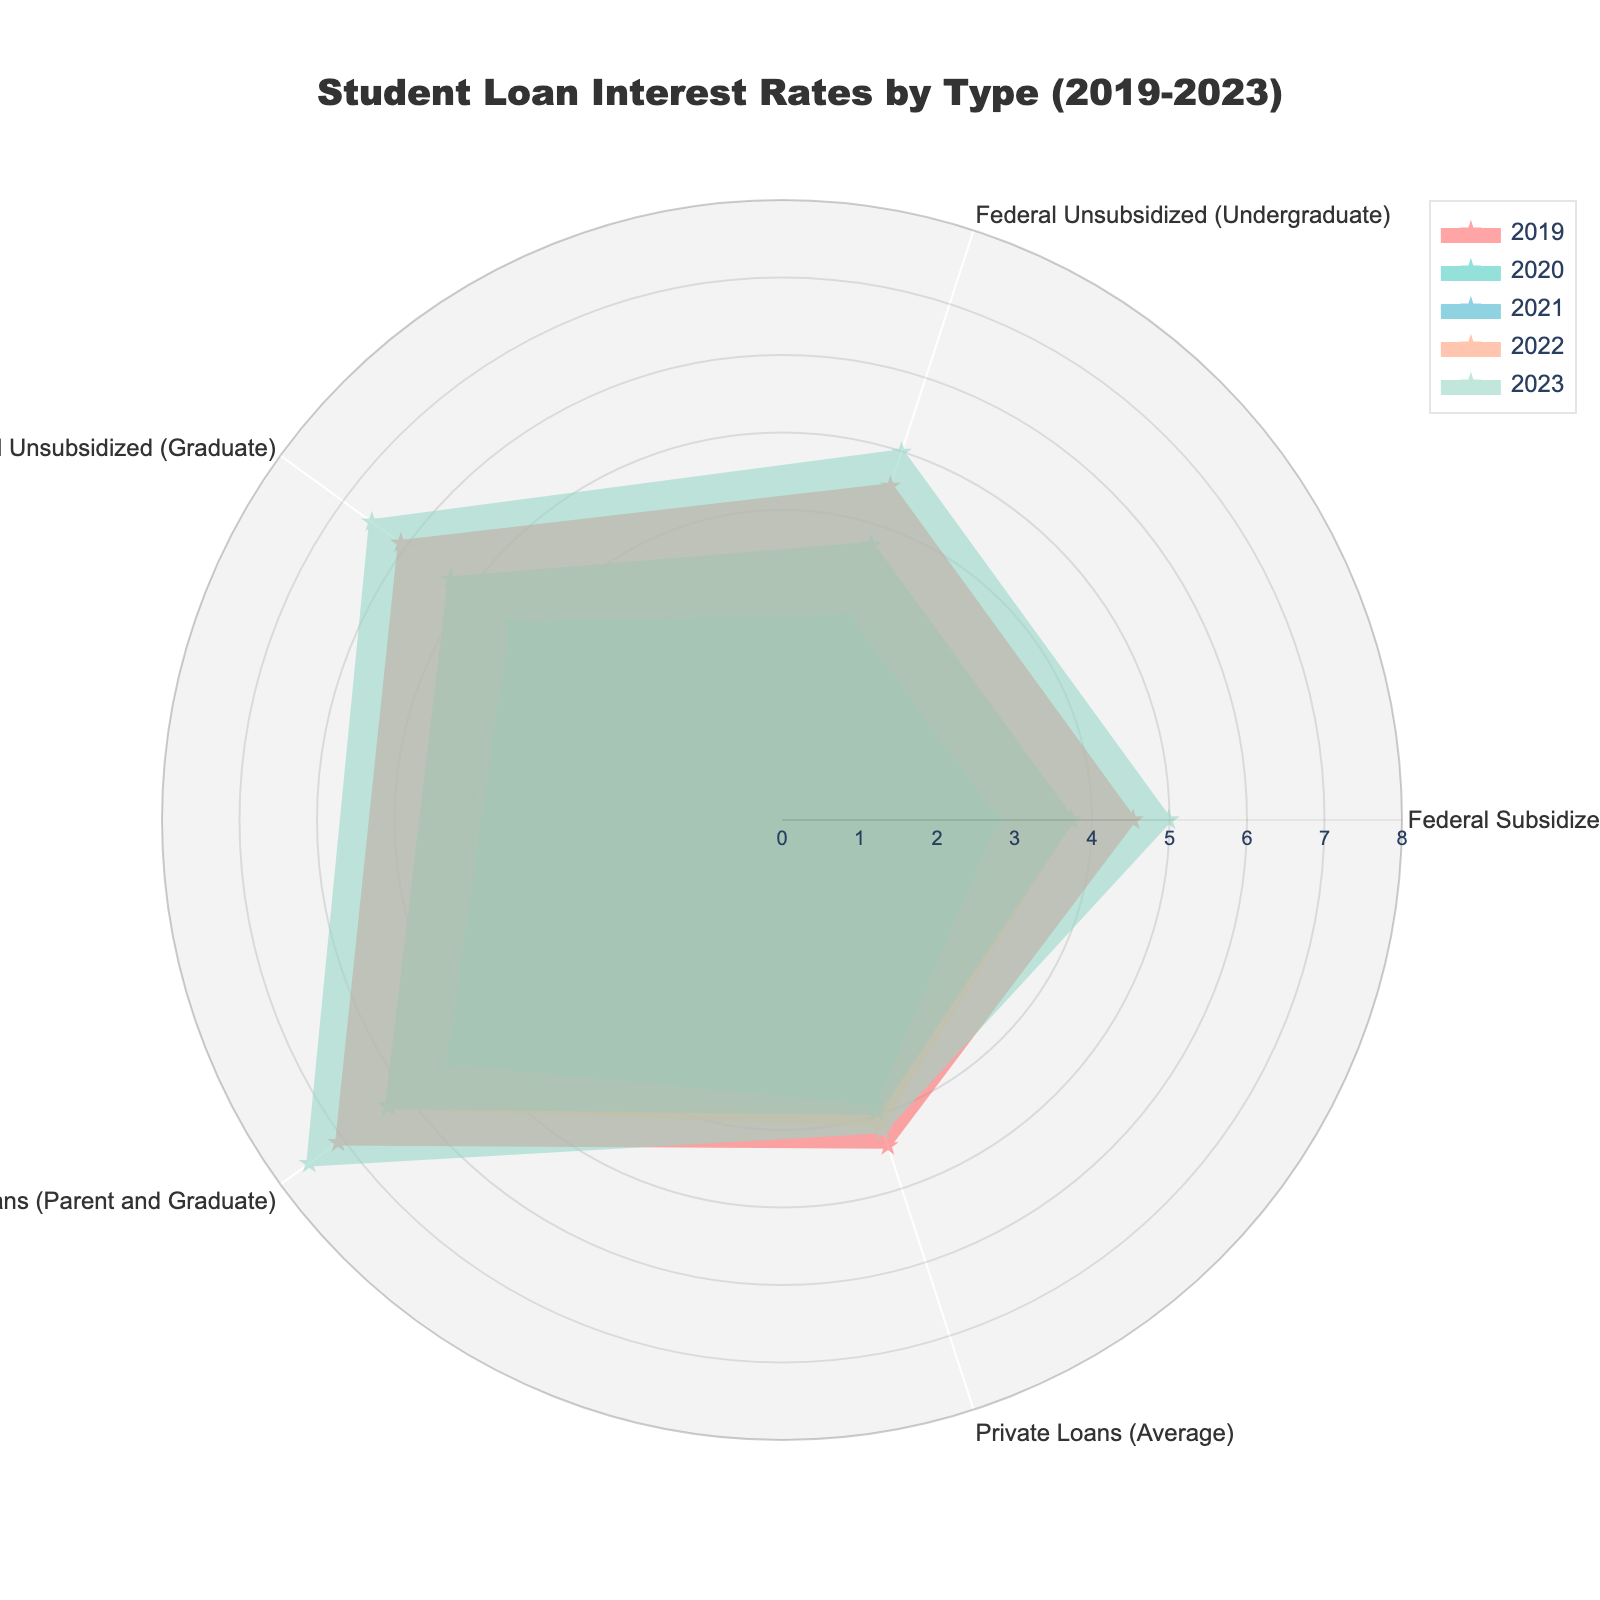What is the title of the radar chart? The title is written on the top of the chart. It reads "Student Loan Interest Rates by Type (2019-2023)".
Answer: Student Loan Interest Rates by Type (2019-2023) Which loan type had the highest interest rate in 2023? By looking at the radar chart's values for the year 2023, determine which loan type has the maximum radius.
Answer: Direct PLUS Loans (Parent and Graduate) How did the interest rate for Federal Unsubsidized (Graduate) loans change from 2020 to 2021? Compare the values for Federal Unsubsidized (Graduate) loans between the years 2020 and 2021. The rate increased from 4.30% to 5.28%.
Answer: Increased What is the average interest rate of Private Loans from 2019 to 2023? Add up all the interest rates for Private Loans over the years and then divide by the number of years (2019 to 2023). (4.42 + 3.83 + 3.96 + 4.12 + 4.21) / 5 = 20.54 / 5 = 4.108
Answer: 4.11 Which year had the lowest overall interest rates for the listed loan types? Look at the radar chart and compare the distribution of interest rates for every year. The year with the lowest range is 2020.
Answer: 2020 Between which years did Direct PLUS Loans (Parent and Graduate) rates change the most? Calculate the differences in interest rates for Direct PLUS Loans across consecutive years and identify the largest change. Between 2019 and 2020, the change was 7.08 - 5.30 = 1.78%.
Answer: 2019 to 2020 Compare the trend of interest rates for Federal Subsidized loans and Private Loans. Which one had more fluctuation between 2019 to 2023? Observe the lines representing Federal Subsidized loans and Private Loans. Federal Subsidized loans show more fluctuation, varying between 4.53%, 2.75%, 3.73%, 3.73%, and 4.99%, while Private Loans vary less.
Answer: Federal Subsidized loans By how much did the Federal Unsubsidized (Undergraduate) loan rate increase from its lowest point to 2023? Identify the lowest point for Federal Unsubsidized (Undergraduate) rates (2.75% in 2020) and subtract it from the 2023 rate (4.99%). The increase is 4.99 - 2.75 = 2.24%.
Answer: 2.24% Which loan type's interest rate remained the same from 2021 to 2022? Compare the interest rate values for each loan type between 2021 and 2022. Both Federal Subsidized and Federal Unsubsidized (Undergraduate) loan rates remained constant at 3.73%.
Answer: Federal Subsidized and Federal Unsubsidized (Undergraduate) In 2023, which loan type had a similar interest rate to its 2019 rate? Compare the 2023 interest rates of each loan type with their corresponding 2019 rates. Private Loans had a 2023 rate (4.21%) close to its 2019 rate (4.42%).
Answer: Private Loans 